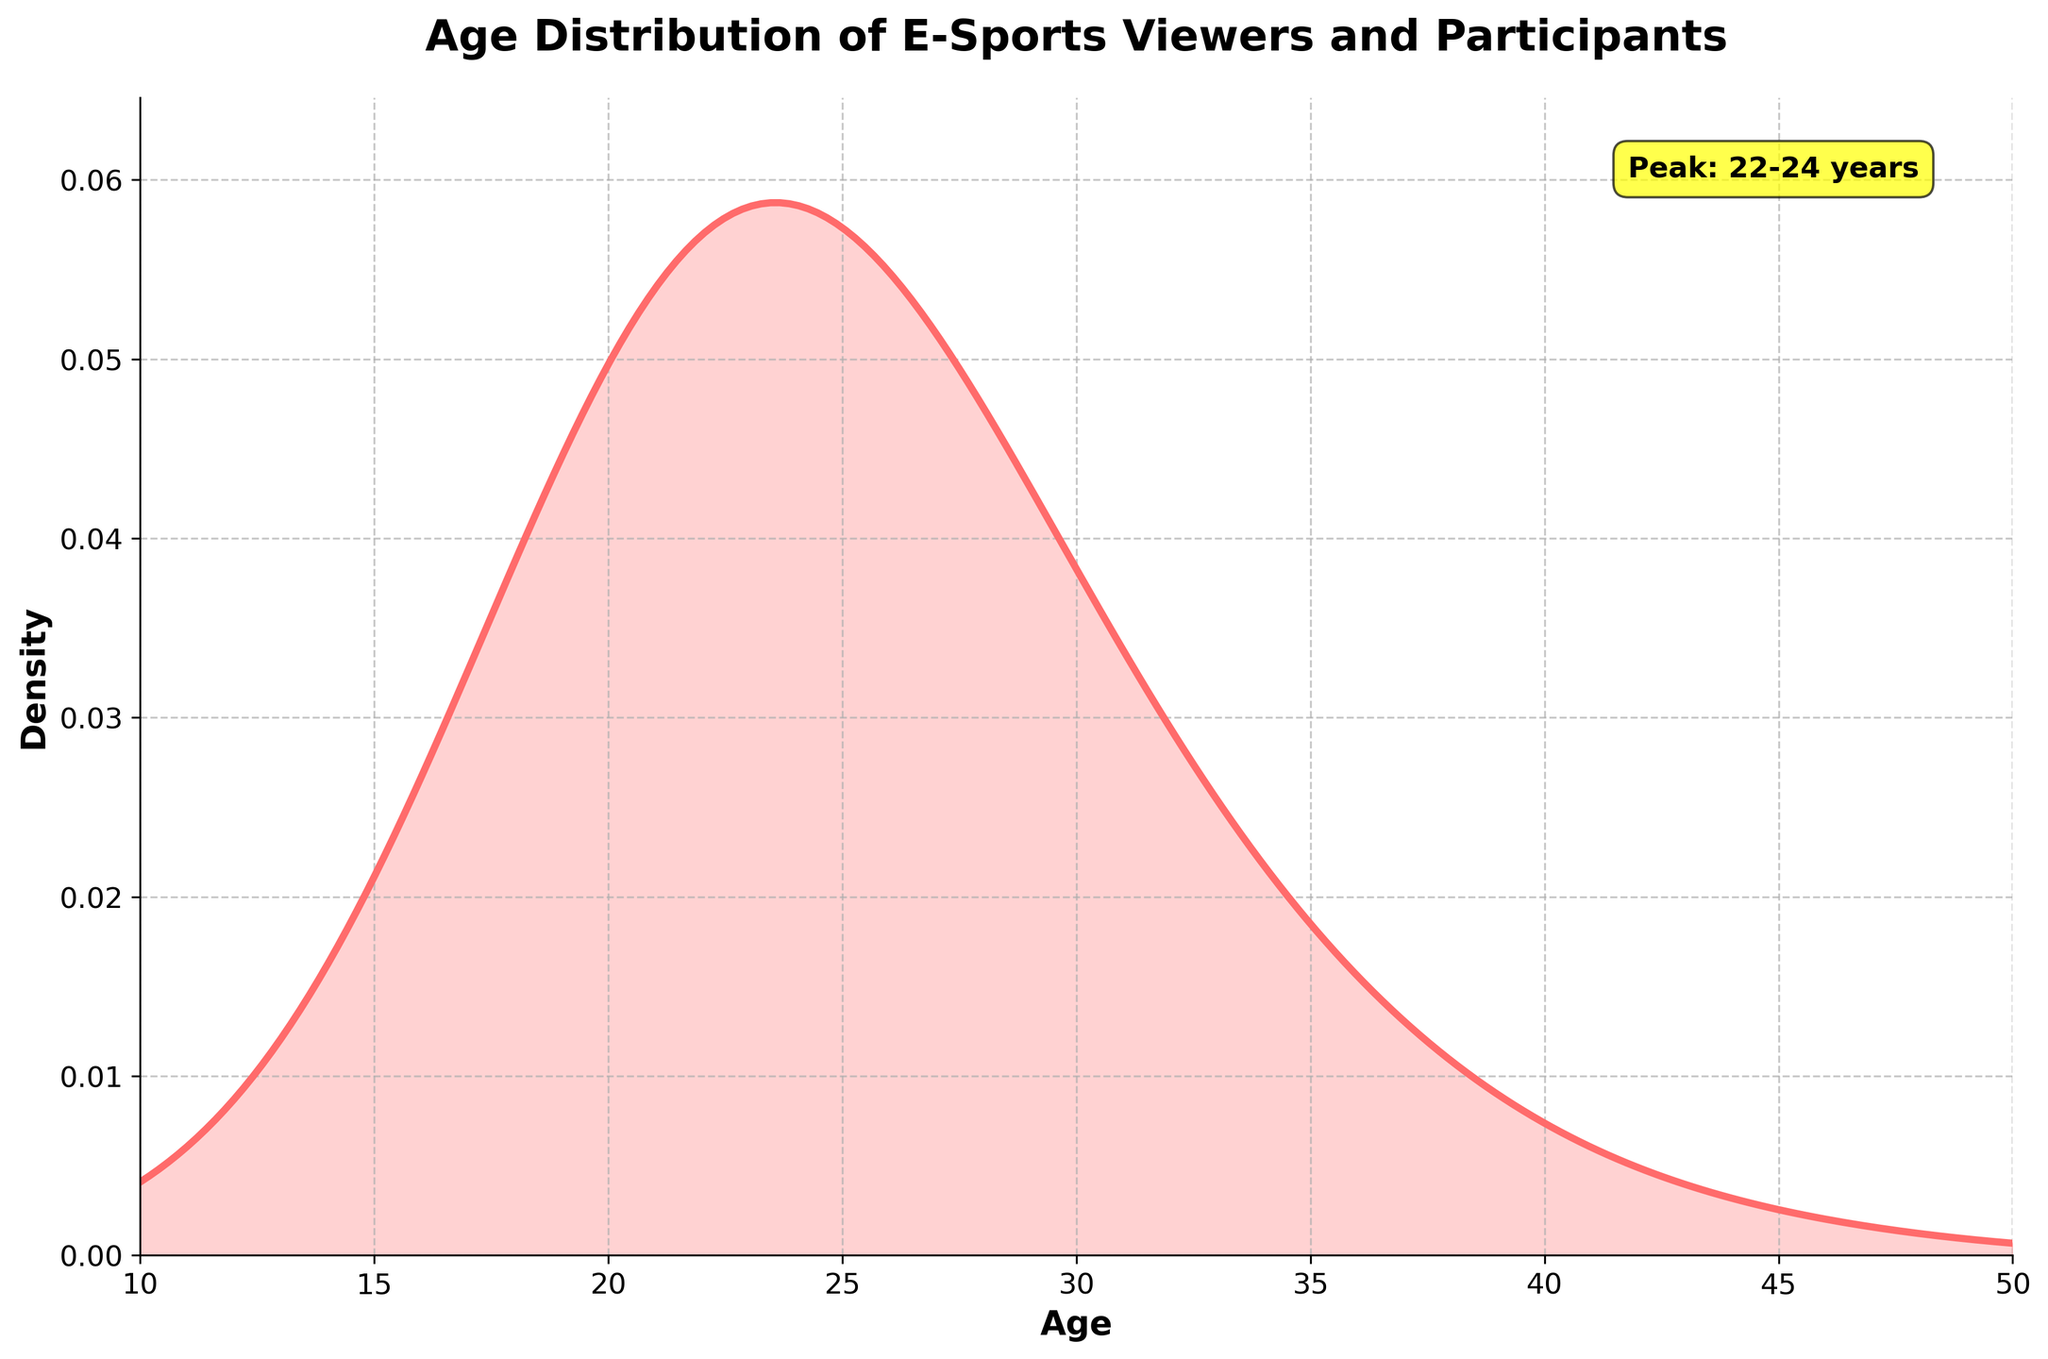What is the title of the plot? Look at the top of the plot where the title is displayed to identify the text shown.
Answer: Age Distribution of E-Sports Viewers and Participants What does the x-axis represent? Check the label on the horizontal axis to determine what it represents.
Answer: Age What does the y-axis represent? Check the label on the vertical axis to understand what it represents.
Answer: Density What is the age range with the highest density of e-sports viewers and participants? Identify the peaks of the density plot to find where the highest density occurs.
Answer: 22-24 years Which color is used to represent the density plot? Observe the color of the plotted line and the filled area under it.
Answer: Red What is the density around age 18? Look at the plot and find the density value corresponding to age 18.
Answer: 0.075 How many data points are there? Observe the total number of scatter points plotted on the figure.
Answer: 19 What age group has a lower density, 26 or 30? Compare the heights of the density values at ages 26 and 30 on the plot.
Answer: 30 Is the density distribution skewed towards a certain age range? Analyze the shape of the plot to determine if it is skewed more towards the younger or older ages.
Answer: Younger ages What is the trend in density from age 12 to age 22? Observe how the density values change in the interval from 12 to 22 years.
Answer: Increasing trend 